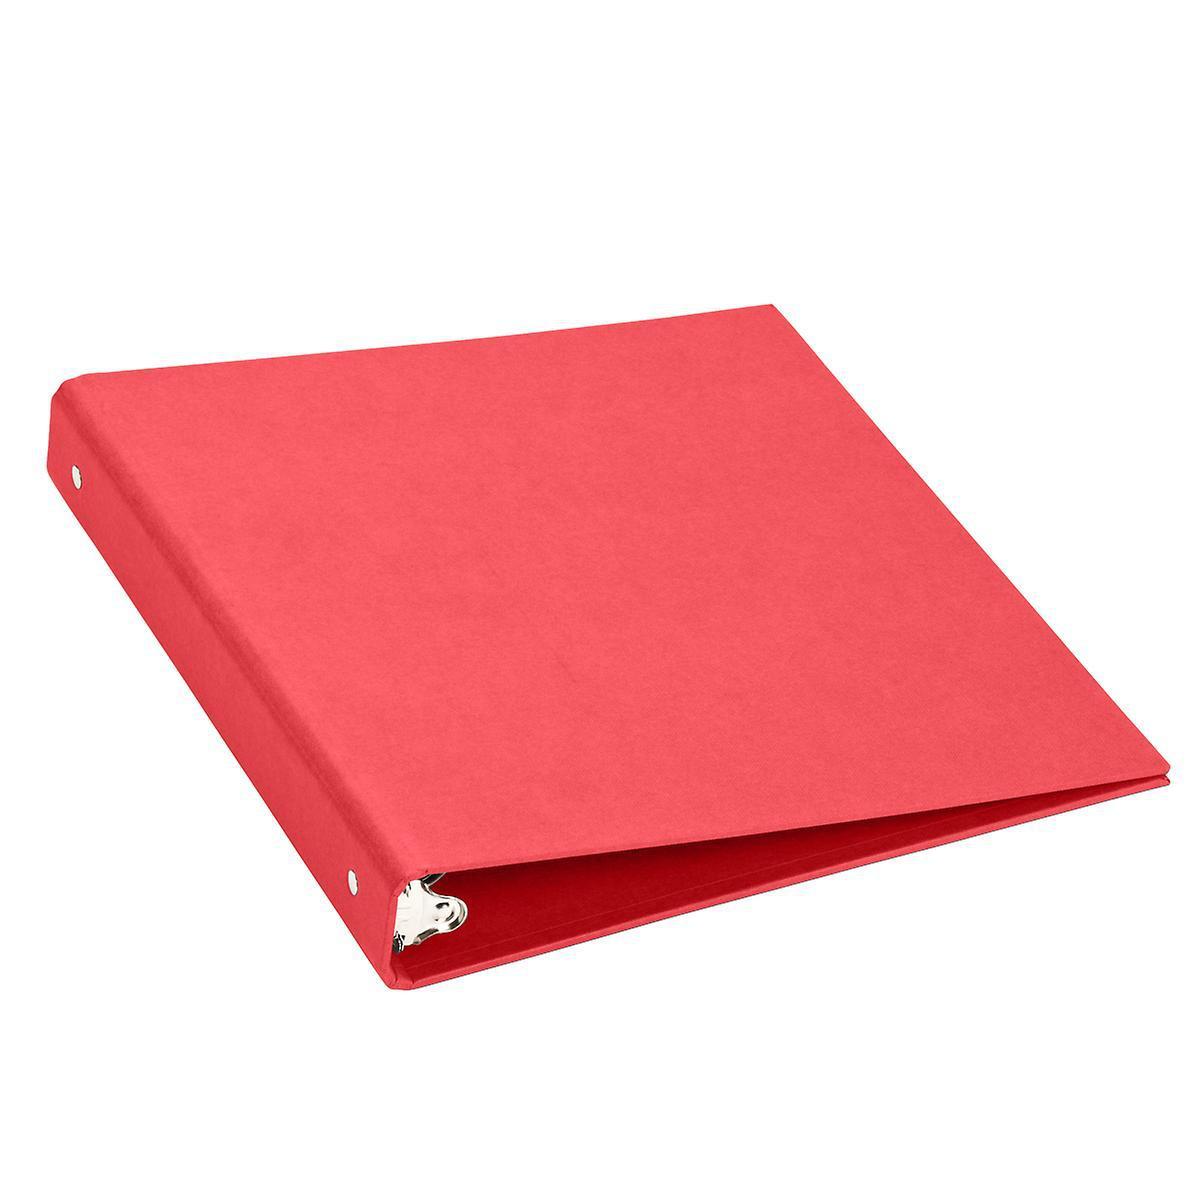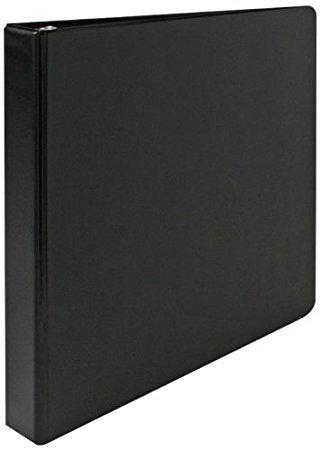The first image is the image on the left, the second image is the image on the right. Assess this claim about the two images: "At least one binder is wide open.". Correct or not? Answer yes or no. No. The first image is the image on the left, the second image is the image on the right. Examine the images to the left and right. Is the description "In one image a blue notebook is standing on end, while the other image shows more than one notebook." accurate? Answer yes or no. No. 